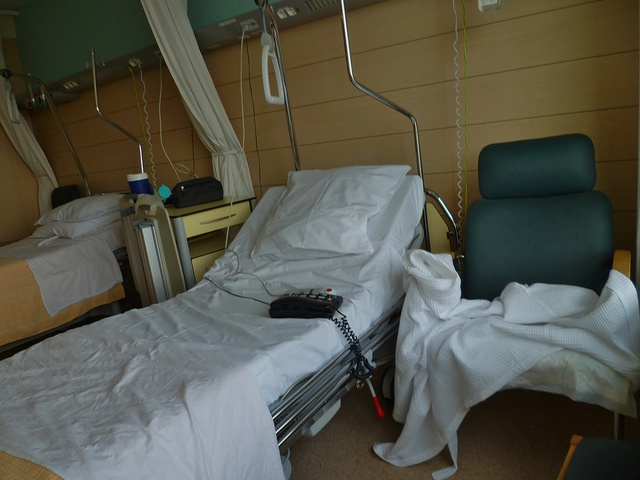Describe the objects in this image and their specific colors. I can see bed in black, gray, and darkgray tones, chair in black, olive, gray, and maroon tones, bed in black, gray, and olive tones, and cup in black, navy, gray, and darkgray tones in this image. 